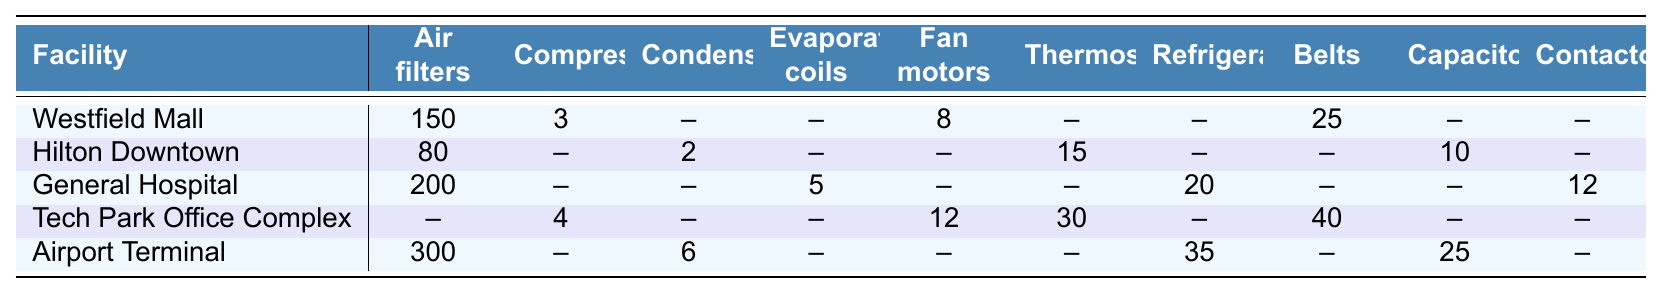What is the total number of air filters available across all facilities? To find the total number of air filters, we can add the values for each facility: Westfield Mall (150) + Hilton Downtown (80) + General Hospital (200) + Tech Park Office Complex (0) + Airport Terminal (300) = 730.
Answer: 730 Which facility has the highest number of compressors? By comparing the values in the compressors column, we see Westfield Mall has 3, Hilton Downtown has 0, General Hospital has 0, Tech Park Office Complex has 4, and Airport Terminal has 0. The highest number is 4 from Tech Park Office Complex.
Answer: Tech Park Office Complex Is there a facility that has no condensers in its inventory? Checking the condensers column, Westfield Mall has none (listed as --), Hilton Downtown has 2, General Hospital has none (listed as --), Tech Park Office Complex has none (listed as --), and Airport Terminal has 6. Facilities with no condensers include Westfield Mall, General Hospital, and Tech Park Office Complex.
Answer: Yes What is the average number of fan motors across all facilities that have them? The facilities with fan motors and their values are Westfield Mall (8), Tech Park Office Complex (12), and no fan motors from Hilton Downtown, General Hospital, and Airport Terminal. We calculate the average with (8 + 12) / 2 = 10.
Answer: 10 Which two facilities have the highest combined number of capacitors? We look at the capacitors column: Hilton Downtown has 10 capacitors, General Hospital has none (listed as --), Tech Park Office Complex has none (listed as --), and Airport Terminal has 25. The highest combined number is from Hilton Downtown (10) and Airport Terminal (25), totaling 10 + 25 = 35.
Answer: 35 What is the difference in the number of refrigerants between General Hospital and Airport Terminal? General Hospital has 20 refrigerants and Airport Terminal has 35. The difference is calculated as 35 - 20 = 15.
Answer: 15 Which facility requires the most fan motors and how many does it require? Reviewing the fan motors column, we find Westfield Mall has 8, Tech Park Office Complex has 12, while Hilton Downtown, General Hospital, and Airport Terminal have none. Tech Park Office Complex has the most with 12.
Answer: Tech Park Office Complex, 12 Are there any facilities that have both thermostats and evaporator coils in stock? Checking the thermostats and evaporator coils columns, we find that the only facility with thermostats is Tech Park Office Complex (30) and the only facility with evaporator coils is General Hospital (5). Since no facility has both, the answer is no.
Answer: No How many total spare parts (of all types) does Airport Terminal have in stock? Adding all available parts for Airport Terminal: Air filters (300) + Condensers (6) + Refrigerant (35) + Capacitors (25) = 300 + 6 + 35 + 25 = 366.
Answer: 366 